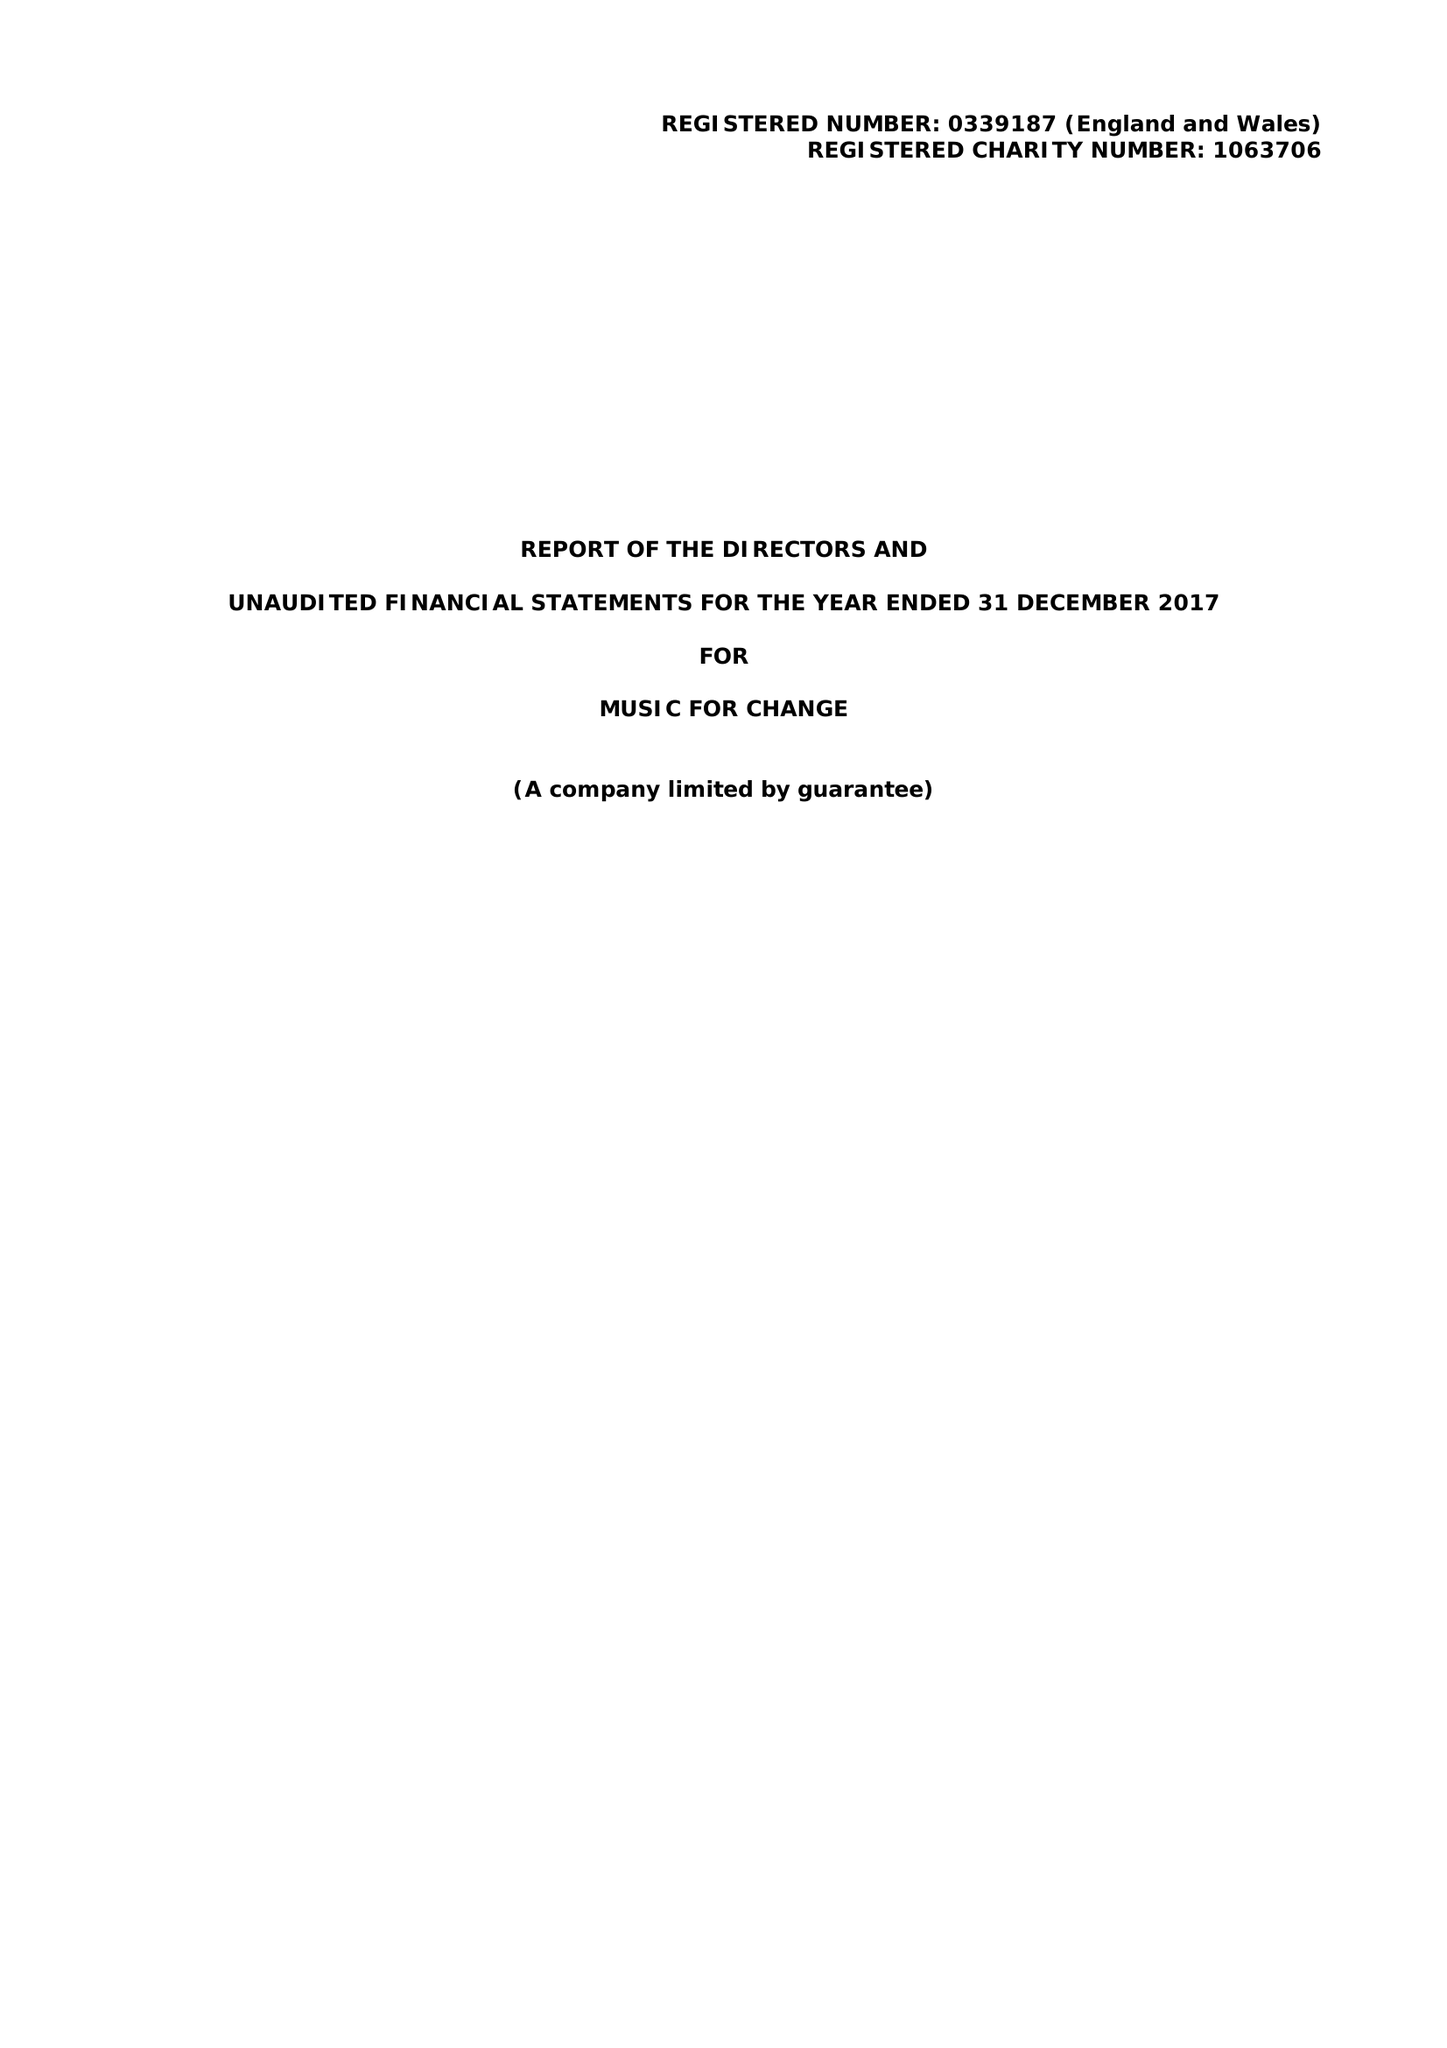What is the value for the address__post_town?
Answer the question using a single word or phrase. CANTERBURY 